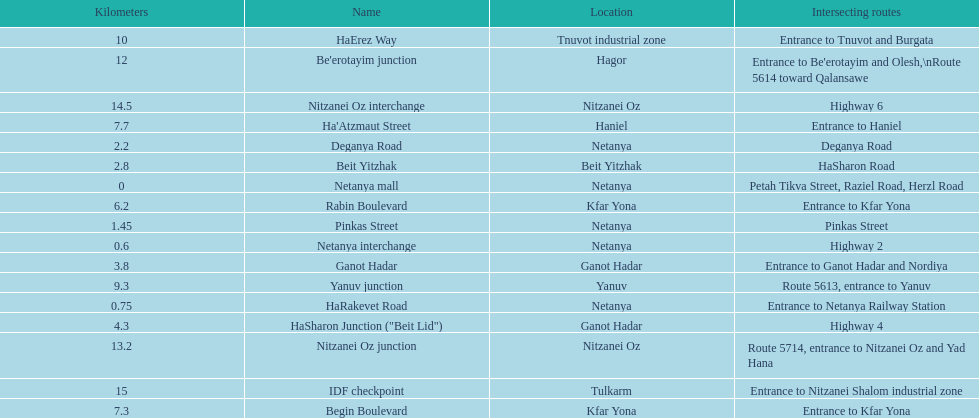In netanya, what is the count of different locations? 5. 